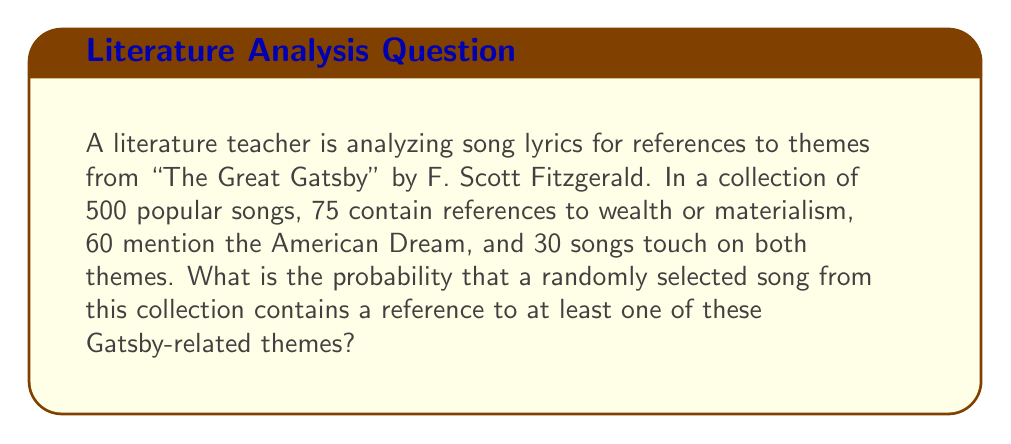Can you answer this question? To solve this problem, we'll use the concept of probability and set theory.

Step 1: Define our sets
Let W = set of songs with wealth/materialism references
Let A = set of songs with American Dream references

Step 2: Calculate the number of songs with at least one theme
We can use the formula: $n(W \cup A) = n(W) + n(A) - n(W \cap A)$
Where:
$n(W) = 75$ (songs about wealth/materialism)
$n(A) = 60$ (songs about American Dream)
$n(W \cap A) = 30$ (songs about both themes)

$n(W \cup A) = 75 + 60 - 30 = 105$ songs

Step 3: Calculate the probability
The probability is the number of favorable outcomes divided by the total number of possible outcomes:

$P(\text{at least one theme}) = \frac{n(W \cup A)}{\text{total number of songs}}$

$P(\text{at least one theme}) = \frac{105}{500} = \frac{21}{100} = 0.21$

Therefore, the probability of selecting a song with at least one Gatsby-related theme is 0.21 or 21%.
Answer: 0.21 